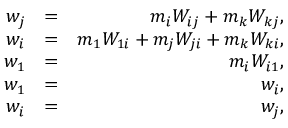<formula> <loc_0><loc_0><loc_500><loc_500>\begin{array} { r l r } { w _ { j } } & { = } & { m _ { i } W _ { i j } + m _ { k } W _ { k j } , } \\ { w _ { i } } & { = } & { m _ { 1 } W _ { 1 i } + m _ { j } W _ { j i } + m _ { k } W _ { k i } , } \\ { w _ { 1 } } & { = } & { m _ { i } W _ { i 1 } , } \\ { w _ { 1 } } & { = } & { w _ { i } , } \\ { w _ { i } } & { = } & { w _ { j } , } \end{array}</formula> 